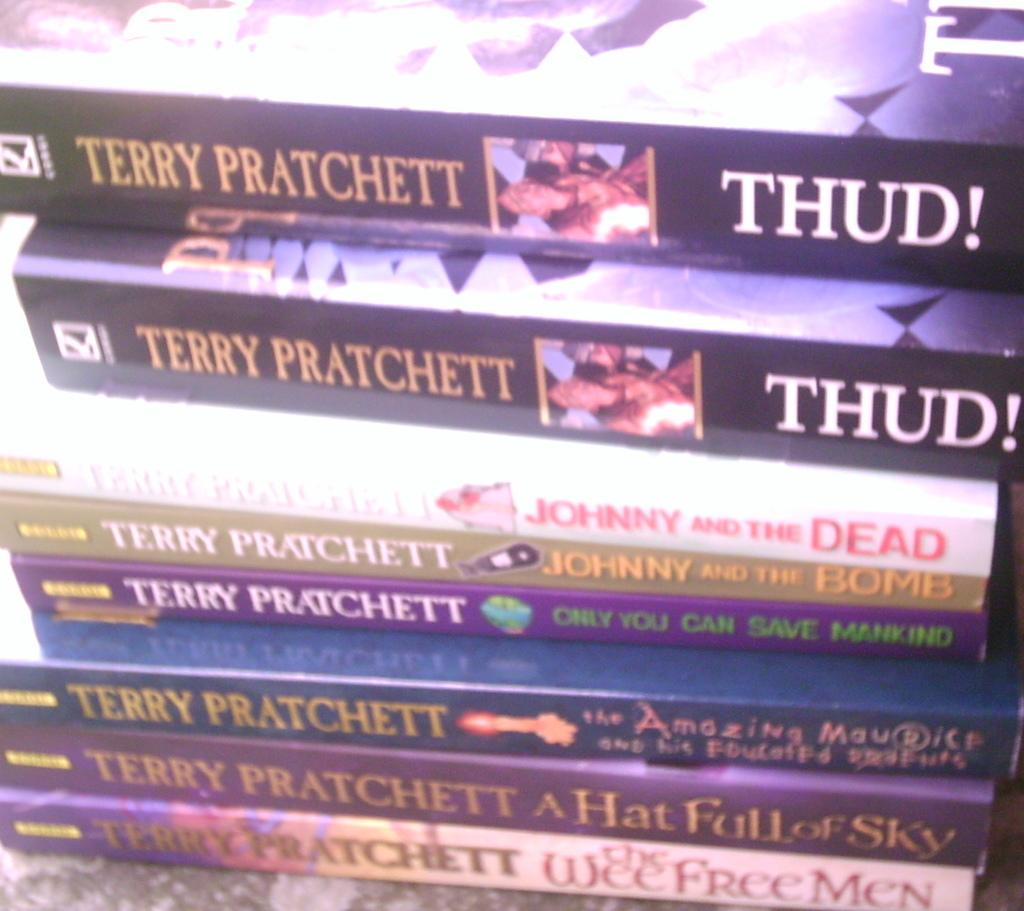<image>
Relay a brief, clear account of the picture shown. Many books on a table and all written by Terry Pratchett. 